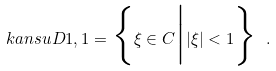Convert formula to latex. <formula><loc_0><loc_0><loc_500><loc_500>\ k a n s u { D } { 1 , 1 } = \Big \{ \xi \in { C } \Big | | \xi | < 1 \Big \} \ .</formula> 